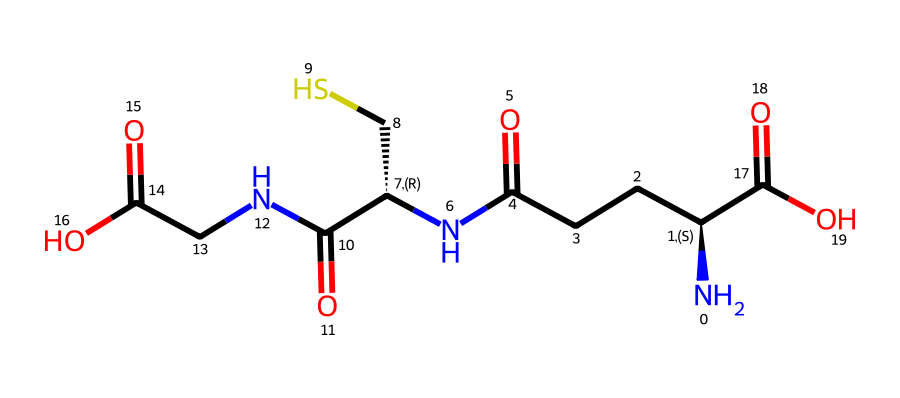how many carbon atoms are present in this structure? By analyzing the SMILES representation, we can count the carbon atoms. The representation shows a series of carbon atoms linked to nitrogen and oxygen. Counting each carbon in the sequence results in a total of 9 carbon atoms.
Answer: 9 what is the function of glutathione in extremophile bacteria? Glutathione acts primarily as an antioxidant within extremophile bacteria, protecting them from oxidative stress caused by extreme environments.
Answer: antioxidant how many nitrogen atoms are in the structure? We can identify the nitrogen atoms by looking at the symbols in the SMILES string. The letter "N" indicates nitrogen, and by counting each occurrence, we find a total of 3 nitrogen atoms present in the structure.
Answer: 3 what type of functional groups are present in this molecule? The molecule contains several functional groups, primarily amines (due to the presence of nitrogen), carboxylic acids (due to the carboxylate groups), and possibly a mercaptan (due to the thiol group, where sulfur is involved). These can be identified by their respective elemental symbols and bonding patterns in the SMILES notation.
Answer: amines, carboxylic acids, thiol what is the significance of the thiol group in glutathione? The thiol group (-SH) in glutathione is crucial for its antioxidant activity as it allows for the reduction of reactive oxygen species, facilitating the neutralization of free radicals. This reducing capacity is essential for the survival of extremophiles in harsh conditions.
Answer: antioxidant activity 